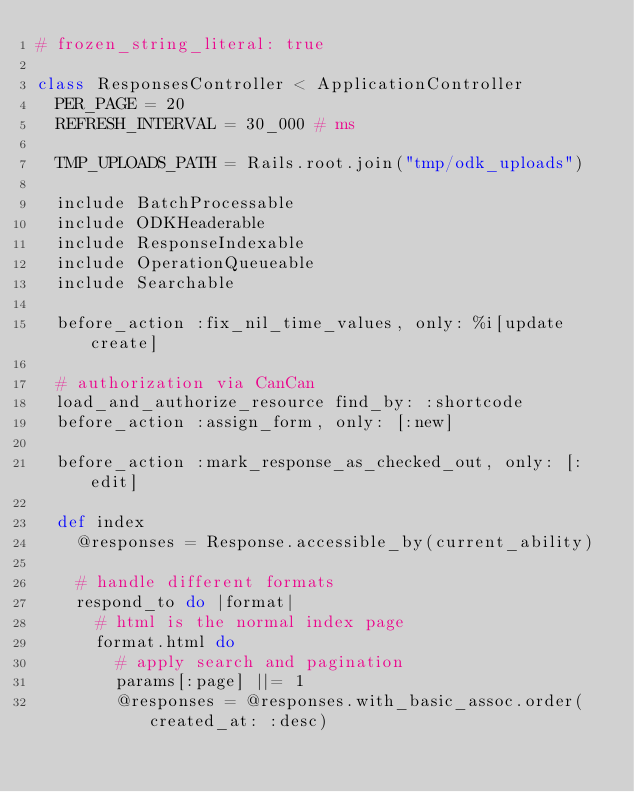Convert code to text. <code><loc_0><loc_0><loc_500><loc_500><_Ruby_># frozen_string_literal: true

class ResponsesController < ApplicationController
  PER_PAGE = 20
  REFRESH_INTERVAL = 30_000 # ms

  TMP_UPLOADS_PATH = Rails.root.join("tmp/odk_uploads")

  include BatchProcessable
  include ODKHeaderable
  include ResponseIndexable
  include OperationQueueable
  include Searchable

  before_action :fix_nil_time_values, only: %i[update create]

  # authorization via CanCan
  load_and_authorize_resource find_by: :shortcode
  before_action :assign_form, only: [:new]

  before_action :mark_response_as_checked_out, only: [:edit]

  def index
    @responses = Response.accessible_by(current_ability)

    # handle different formats
    respond_to do |format|
      # html is the normal index page
      format.html do
        # apply search and pagination
        params[:page] ||= 1
        @responses = @responses.with_basic_assoc.order(created_at: :desc)</code> 